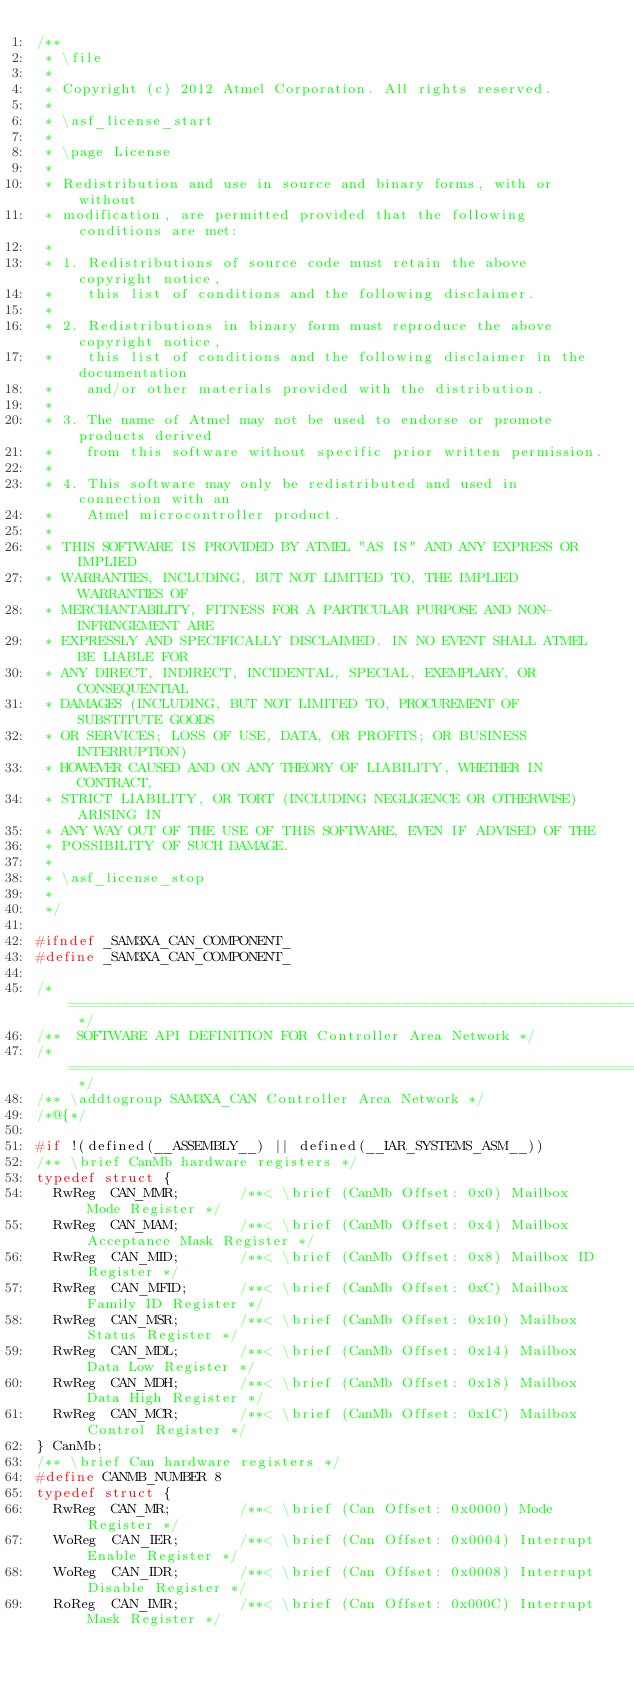<code> <loc_0><loc_0><loc_500><loc_500><_C_>/**
 * \file
 *
 * Copyright (c) 2012 Atmel Corporation. All rights reserved.
 *
 * \asf_license_start
 *
 * \page License
 *
 * Redistribution and use in source and binary forms, with or without
 * modification, are permitted provided that the following conditions are met:
 *
 * 1. Redistributions of source code must retain the above copyright notice,
 *    this list of conditions and the following disclaimer.
 *
 * 2. Redistributions in binary form must reproduce the above copyright notice,
 *    this list of conditions and the following disclaimer in the documentation
 *    and/or other materials provided with the distribution.
 *
 * 3. The name of Atmel may not be used to endorse or promote products derived
 *    from this software without specific prior written permission.
 *
 * 4. This software may only be redistributed and used in connection with an
 *    Atmel microcontroller product.
 *
 * THIS SOFTWARE IS PROVIDED BY ATMEL "AS IS" AND ANY EXPRESS OR IMPLIED
 * WARRANTIES, INCLUDING, BUT NOT LIMITED TO, THE IMPLIED WARRANTIES OF
 * MERCHANTABILITY, FITNESS FOR A PARTICULAR PURPOSE AND NON-INFRINGEMENT ARE
 * EXPRESSLY AND SPECIFICALLY DISCLAIMED. IN NO EVENT SHALL ATMEL BE LIABLE FOR
 * ANY DIRECT, INDIRECT, INCIDENTAL, SPECIAL, EXEMPLARY, OR CONSEQUENTIAL
 * DAMAGES (INCLUDING, BUT NOT LIMITED TO, PROCUREMENT OF SUBSTITUTE GOODS
 * OR SERVICES; LOSS OF USE, DATA, OR PROFITS; OR BUSINESS INTERRUPTION)
 * HOWEVER CAUSED AND ON ANY THEORY OF LIABILITY, WHETHER IN CONTRACT,
 * STRICT LIABILITY, OR TORT (INCLUDING NEGLIGENCE OR OTHERWISE) ARISING IN
 * ANY WAY OUT OF THE USE OF THIS SOFTWARE, EVEN IF ADVISED OF THE
 * POSSIBILITY OF SUCH DAMAGE.
 *
 * \asf_license_stop
 *
 */

#ifndef _SAM3XA_CAN_COMPONENT_
#define _SAM3XA_CAN_COMPONENT_

/* ============================================================================= */
/**  SOFTWARE API DEFINITION FOR Controller Area Network */
/* ============================================================================= */
/** \addtogroup SAM3XA_CAN Controller Area Network */
/*@{*/

#if !(defined(__ASSEMBLY__) || defined(__IAR_SYSTEMS_ASM__))
/** \brief CanMb hardware registers */
typedef struct {
  RwReg  CAN_MMR;       /**< \brief (CanMb Offset: 0x0) Mailbox Mode Register */
  RwReg  CAN_MAM;       /**< \brief (CanMb Offset: 0x4) Mailbox Acceptance Mask Register */
  RwReg  CAN_MID;       /**< \brief (CanMb Offset: 0x8) Mailbox ID Register */
  RwReg  CAN_MFID;      /**< \brief (CanMb Offset: 0xC) Mailbox Family ID Register */
  RwReg  CAN_MSR;       /**< \brief (CanMb Offset: 0x10) Mailbox Status Register */
  RwReg  CAN_MDL;       /**< \brief (CanMb Offset: 0x14) Mailbox Data Low Register */
  RwReg  CAN_MDH;       /**< \brief (CanMb Offset: 0x18) Mailbox Data High Register */
  RwReg  CAN_MCR;       /**< \brief (CanMb Offset: 0x1C) Mailbox Control Register */
} CanMb;
/** \brief Can hardware registers */
#define CANMB_NUMBER 8
typedef struct {
  RwReg  CAN_MR;        /**< \brief (Can Offset: 0x0000) Mode Register */
  WoReg  CAN_IER;       /**< \brief (Can Offset: 0x0004) Interrupt Enable Register */
  WoReg  CAN_IDR;       /**< \brief (Can Offset: 0x0008) Interrupt Disable Register */
  RoReg  CAN_IMR;       /**< \brief (Can Offset: 0x000C) Interrupt Mask Register */</code> 